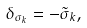Convert formula to latex. <formula><loc_0><loc_0><loc_500><loc_500>\delta _ { \sigma _ { k } } = - \tilde { \sigma } _ { k } ,</formula> 